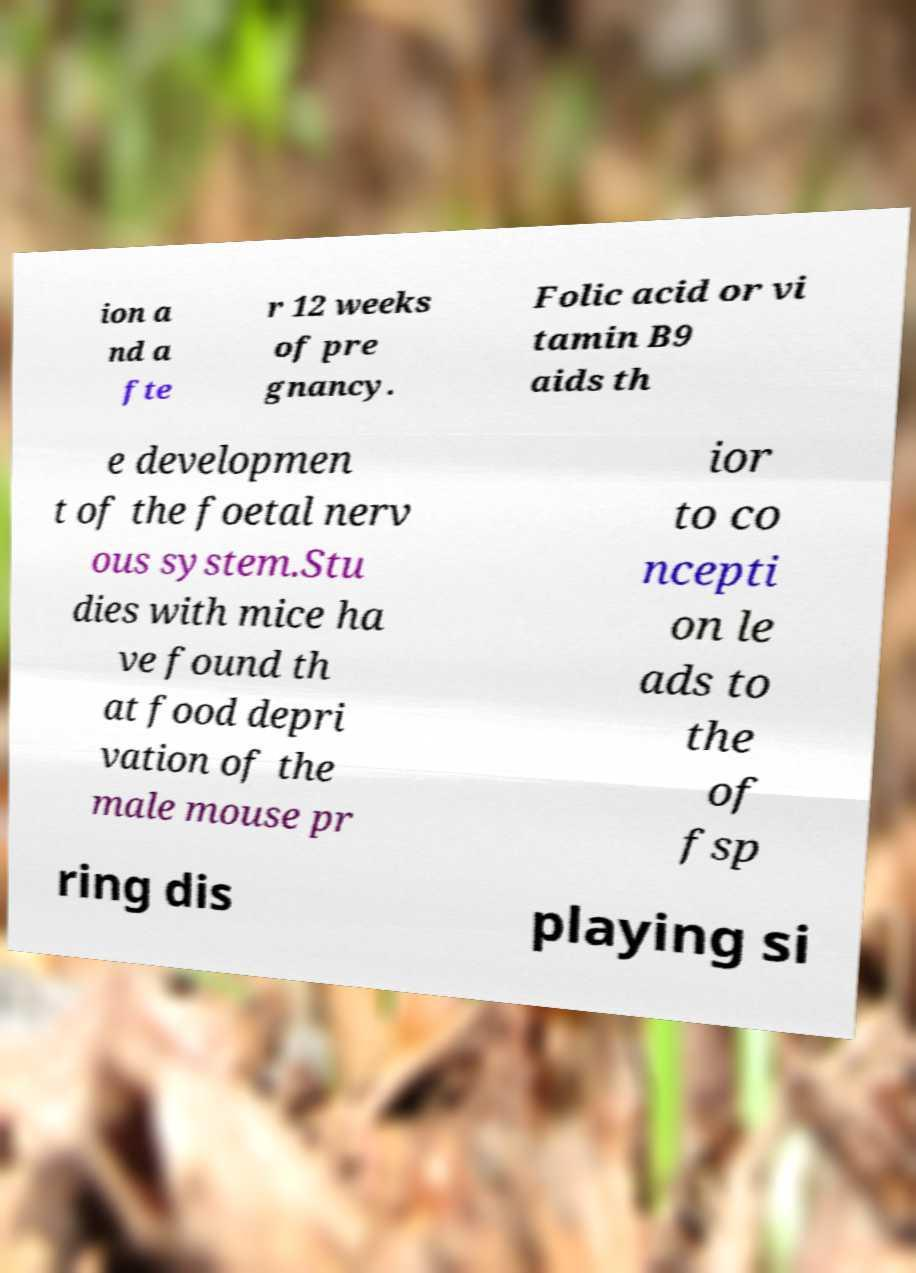What messages or text are displayed in this image? I need them in a readable, typed format. ion a nd a fte r 12 weeks of pre gnancy. Folic acid or vi tamin B9 aids th e developmen t of the foetal nerv ous system.Stu dies with mice ha ve found th at food depri vation of the male mouse pr ior to co ncepti on le ads to the of fsp ring dis playing si 